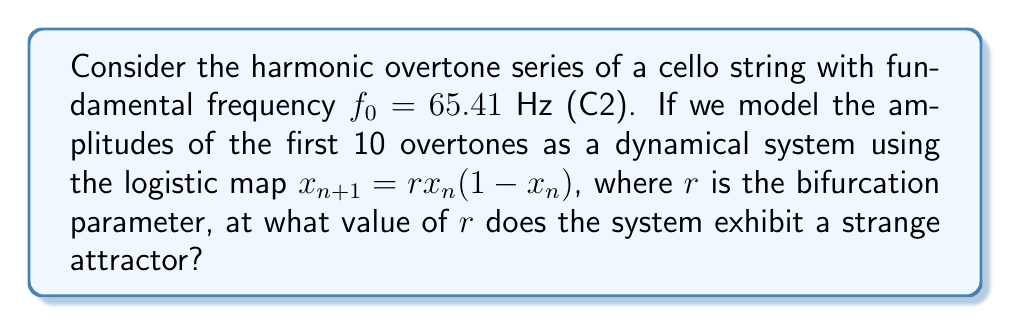Provide a solution to this math problem. To solve this problem, we need to follow these steps:

1) First, recall that the logistic map is given by:
   $$x_{n+1} = rx_n(1-x_n)$$
   where $r$ is the bifurcation parameter.

2) The logistic map exhibits different behaviors for different values of $r$:
   - For $0 < r < 1$, the population will eventually die out.
   - For $1 < r < 3$, the population will quickly stabilize on a single value.
   - For $3 < r < 3.57$, the population will oscillate between two or more values.
   - For $r > 3.57$, the population will exhibit chaotic behavior.

3) A strange attractor is a characteristic of chaotic systems. It appears when the system enters a chaotic regime.

4) For the logistic map, chaos begins when $r > 3.57$.

5) However, not all chaotic regimes exhibit strange attractors. The first appearance of a strange attractor in the logistic map occurs at:
   $$r \approx 3.82843$$

6) This value is known as the Feigenbaum point, named after Mitchell Feigenbaum who discovered it.

7) At this point, the system transitions from a period-doubling cascade to chaos, and a strange attractor emerges.

8) In the context of the cello's harmonic overtones, this would mean that at $r \approx 3.82843$, the amplitudes of the overtones would exhibit complex, unpredictable behavior while still being confined to a specific range (the attractor).
Answer: $r \approx 3.82843$ 